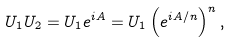Convert formula to latex. <formula><loc_0><loc_0><loc_500><loc_500>U _ { 1 } U _ { 2 } = U _ { 1 } e ^ { i A } = U _ { 1 } \left ( e ^ { i A / n } \right ) ^ { n } ,</formula> 